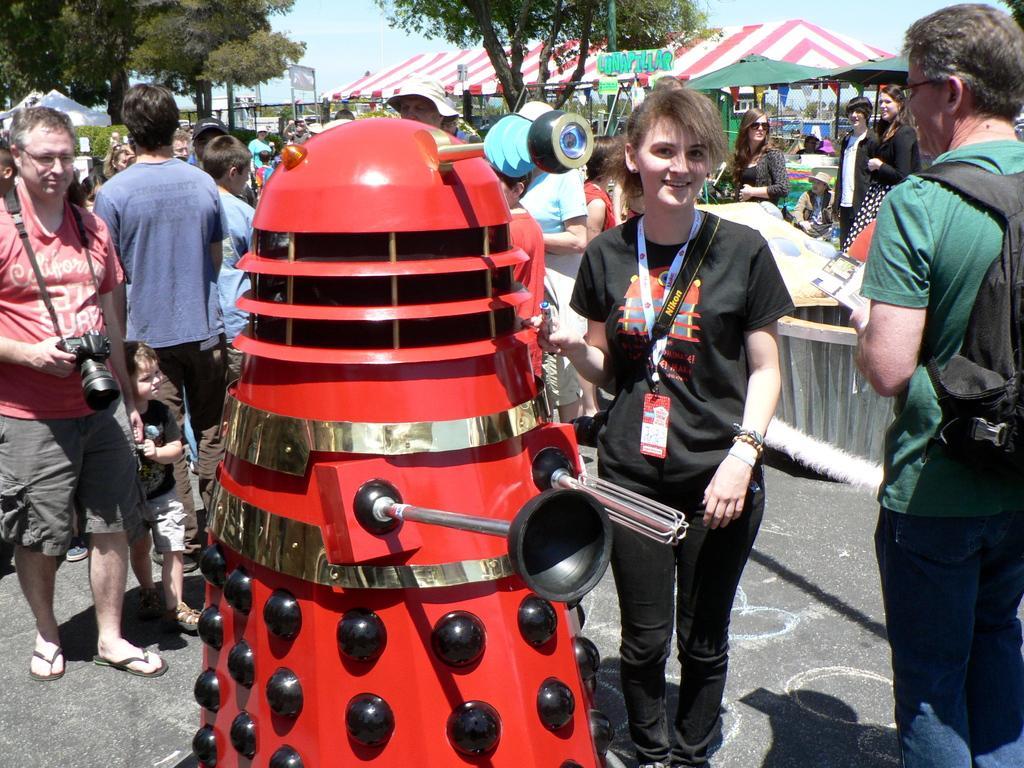Can you describe this image briefly? In this picture I can see a robot, there are group of people standing, there are umbrellas, there are canopy tents, there are trees, there are decorative flags, and in the background there is the sky. 